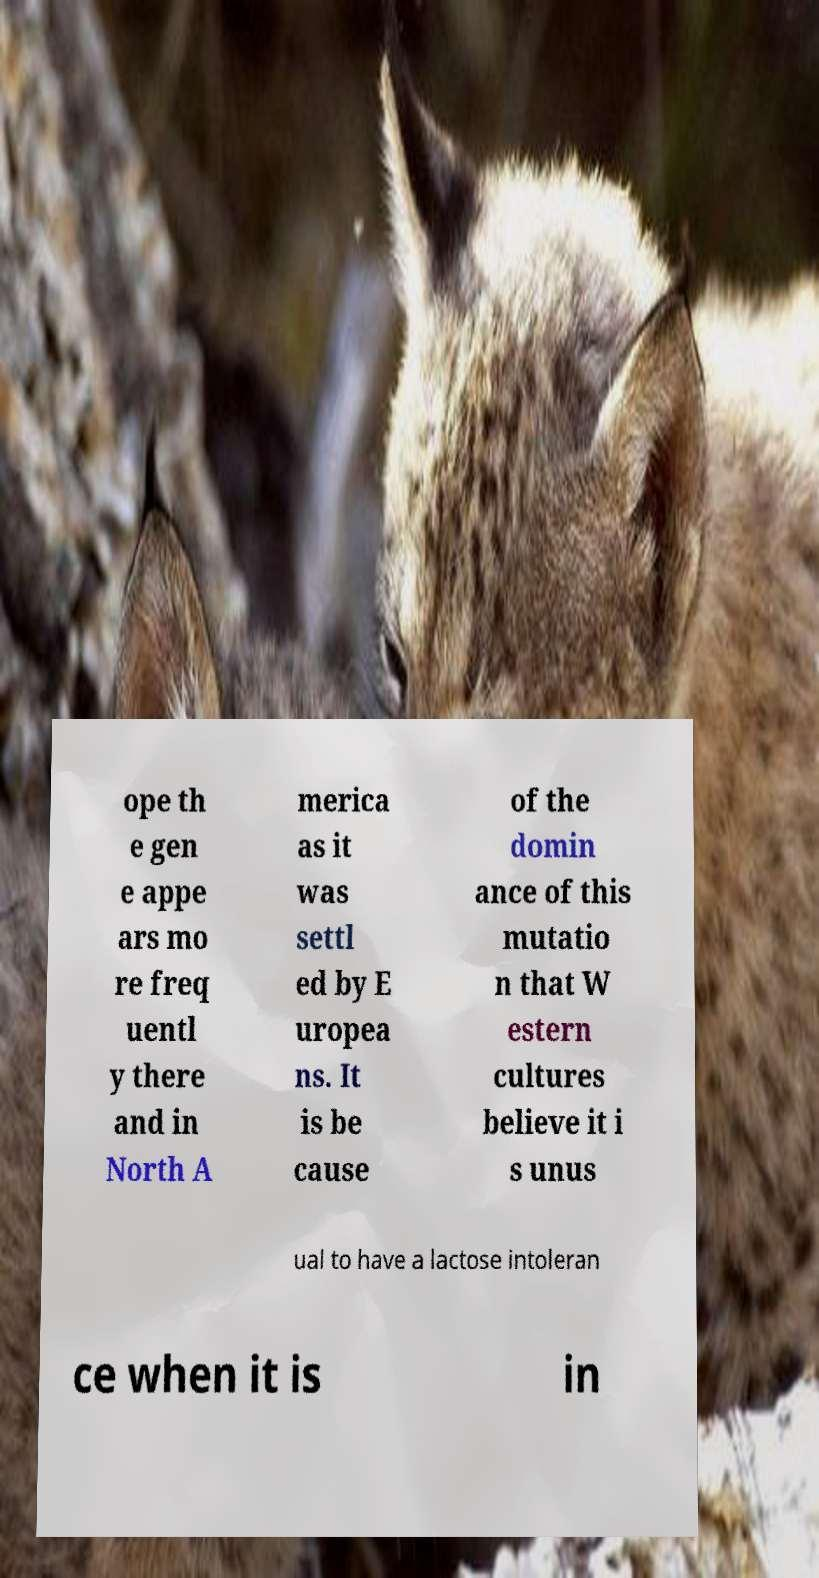For documentation purposes, I need the text within this image transcribed. Could you provide that? ope th e gen e appe ars mo re freq uentl y there and in North A merica as it was settl ed by E uropea ns. It is be cause of the domin ance of this mutatio n that W estern cultures believe it i s unus ual to have a lactose intoleran ce when it is in 